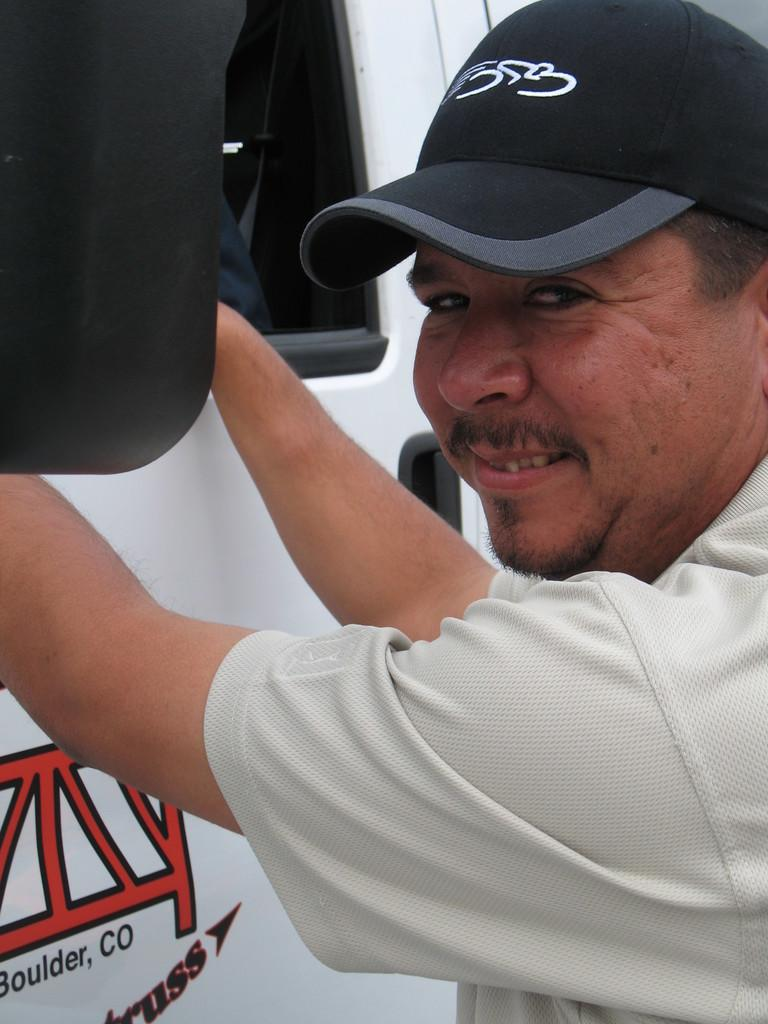Who or what is present in the image? There is a person in the image. What is the person wearing on their head? The person is wearing a cap. What can be seen near the person in the image? There is a vehicle beside the person. What type of notebook is the person holding in the image? There is no notebook present in the image. What is the person doing to stop the vehicle in the image? The person is not shown interacting with the vehicle in any way, so it is not possible to determine if they are trying to stop it. 